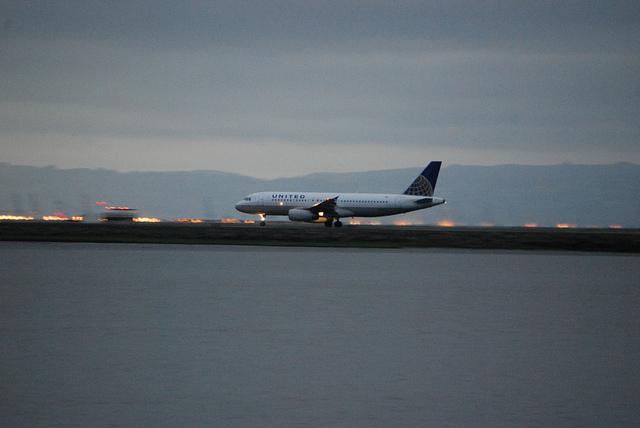Is this a romantic scene?
Keep it brief. No. What time of day is it?
Short answer required. Evening. Is the plain taking off?
Quick response, please. No. Is it daytime?
Concise answer only. No. Is the plane on the runway?
Be succinct. Yes. What airline is this?
Quick response, please. United. What method of mass transit is shown?
Be succinct. Airplane. 